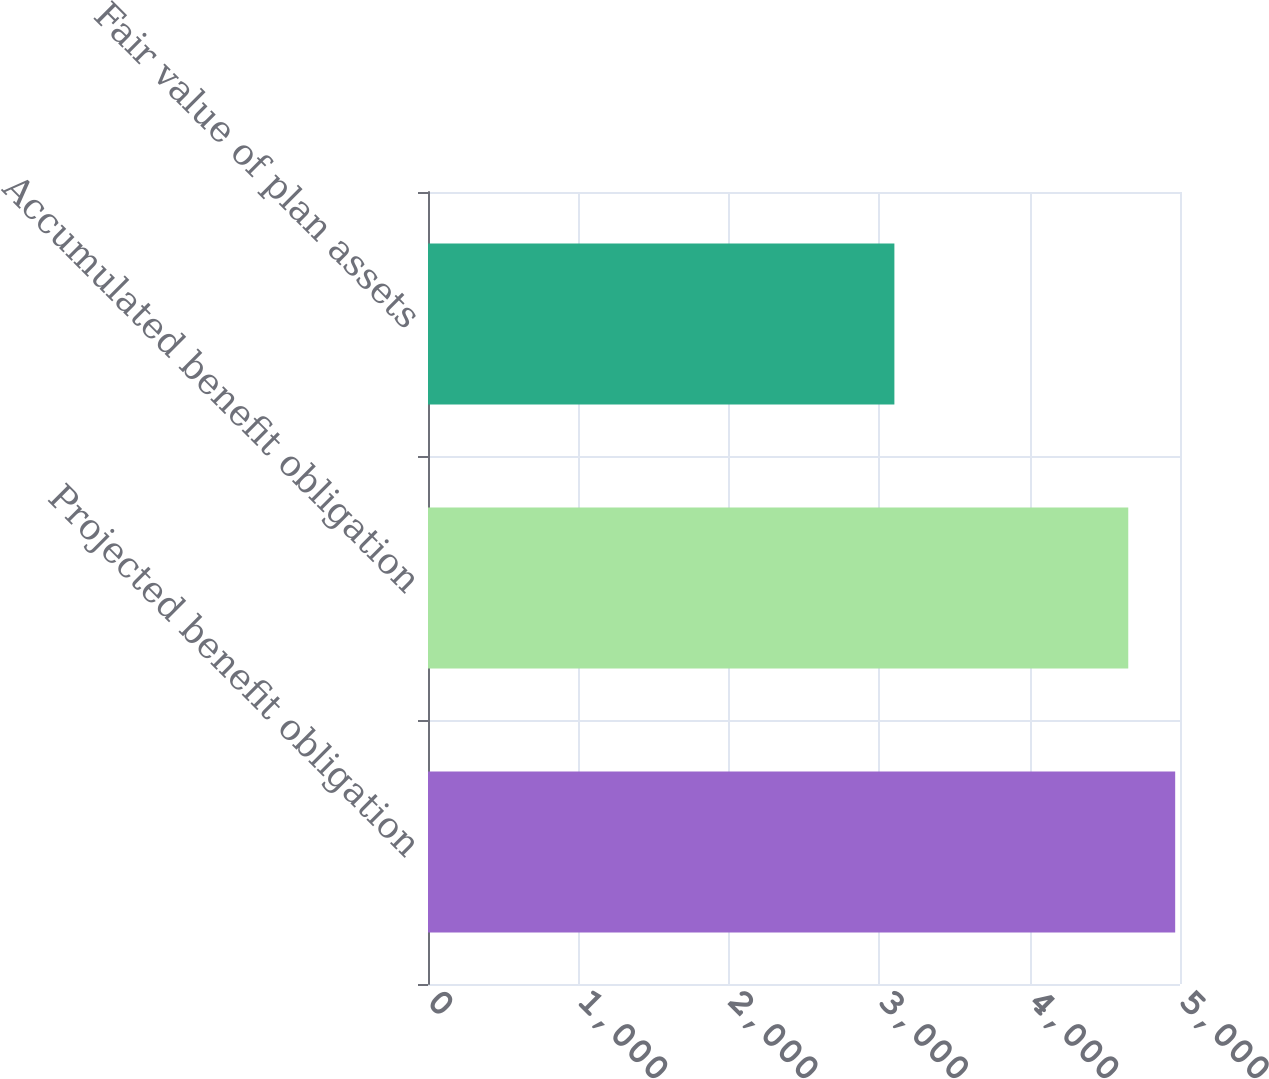Convert chart to OTSL. <chart><loc_0><loc_0><loc_500><loc_500><bar_chart><fcel>Projected benefit obligation<fcel>Accumulated benefit obligation<fcel>Fair value of plan assets<nl><fcel>4968<fcel>4656<fcel>3101<nl></chart> 